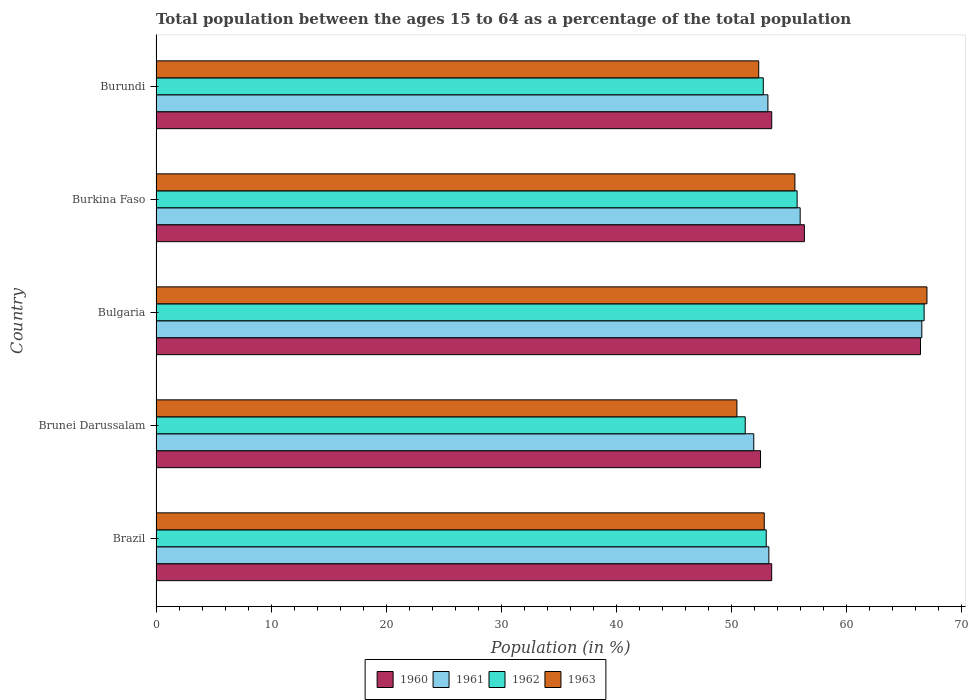How many different coloured bars are there?
Give a very brief answer. 4. How many groups of bars are there?
Your answer should be very brief. 5. Are the number of bars on each tick of the Y-axis equal?
Your answer should be very brief. Yes. What is the label of the 2nd group of bars from the top?
Your answer should be very brief. Burkina Faso. In how many cases, is the number of bars for a given country not equal to the number of legend labels?
Keep it short and to the point. 0. What is the percentage of the population ages 15 to 64 in 1960 in Burkina Faso?
Ensure brevity in your answer.  56.35. Across all countries, what is the maximum percentage of the population ages 15 to 64 in 1963?
Offer a terse response. 67. Across all countries, what is the minimum percentage of the population ages 15 to 64 in 1960?
Make the answer very short. 52.54. In which country was the percentage of the population ages 15 to 64 in 1961 minimum?
Give a very brief answer. Brunei Darussalam. What is the total percentage of the population ages 15 to 64 in 1961 in the graph?
Offer a terse response. 280.93. What is the difference between the percentage of the population ages 15 to 64 in 1960 in Brunei Darussalam and that in Bulgaria?
Your response must be concise. -13.9. What is the difference between the percentage of the population ages 15 to 64 in 1962 in Burkina Faso and the percentage of the population ages 15 to 64 in 1960 in Brazil?
Your answer should be compact. 2.21. What is the average percentage of the population ages 15 to 64 in 1961 per country?
Your response must be concise. 56.19. What is the difference between the percentage of the population ages 15 to 64 in 1960 and percentage of the population ages 15 to 64 in 1963 in Burkina Faso?
Ensure brevity in your answer.  0.82. In how many countries, is the percentage of the population ages 15 to 64 in 1960 greater than 60 ?
Make the answer very short. 1. What is the ratio of the percentage of the population ages 15 to 64 in 1961 in Bulgaria to that in Burkina Faso?
Your answer should be very brief. 1.19. Is the difference between the percentage of the population ages 15 to 64 in 1960 in Bulgaria and Burkina Faso greater than the difference between the percentage of the population ages 15 to 64 in 1963 in Bulgaria and Burkina Faso?
Ensure brevity in your answer.  No. What is the difference between the highest and the second highest percentage of the population ages 15 to 64 in 1963?
Provide a succinct answer. 11.48. What is the difference between the highest and the lowest percentage of the population ages 15 to 64 in 1962?
Provide a succinct answer. 15.55. Is it the case that in every country, the sum of the percentage of the population ages 15 to 64 in 1962 and percentage of the population ages 15 to 64 in 1960 is greater than the sum of percentage of the population ages 15 to 64 in 1963 and percentage of the population ages 15 to 64 in 1961?
Provide a succinct answer. No. What does the 1st bar from the top in Burkina Faso represents?
Make the answer very short. 1963. What does the 1st bar from the bottom in Burundi represents?
Offer a very short reply. 1960. Is it the case that in every country, the sum of the percentage of the population ages 15 to 64 in 1960 and percentage of the population ages 15 to 64 in 1962 is greater than the percentage of the population ages 15 to 64 in 1963?
Keep it short and to the point. Yes. How many bars are there?
Keep it short and to the point. 20. Are all the bars in the graph horizontal?
Make the answer very short. Yes. How many countries are there in the graph?
Make the answer very short. 5. Does the graph contain any zero values?
Offer a very short reply. No. Does the graph contain grids?
Offer a terse response. No. How are the legend labels stacked?
Ensure brevity in your answer.  Horizontal. What is the title of the graph?
Keep it short and to the point. Total population between the ages 15 to 64 as a percentage of the total population. Does "1968" appear as one of the legend labels in the graph?
Your response must be concise. No. What is the label or title of the Y-axis?
Provide a short and direct response. Country. What is the Population (in %) of 1960 in Brazil?
Ensure brevity in your answer.  53.51. What is the Population (in %) of 1961 in Brazil?
Provide a succinct answer. 53.26. What is the Population (in %) in 1962 in Brazil?
Keep it short and to the point. 53.03. What is the Population (in %) of 1963 in Brazil?
Your response must be concise. 52.86. What is the Population (in %) in 1960 in Brunei Darussalam?
Offer a very short reply. 52.54. What is the Population (in %) in 1961 in Brunei Darussalam?
Provide a succinct answer. 51.95. What is the Population (in %) of 1962 in Brunei Darussalam?
Offer a very short reply. 51.21. What is the Population (in %) of 1963 in Brunei Darussalam?
Provide a succinct answer. 50.48. What is the Population (in %) of 1960 in Bulgaria?
Ensure brevity in your answer.  66.44. What is the Population (in %) of 1961 in Bulgaria?
Your response must be concise. 66.56. What is the Population (in %) in 1962 in Bulgaria?
Provide a succinct answer. 66.76. What is the Population (in %) of 1963 in Bulgaria?
Offer a terse response. 67. What is the Population (in %) of 1960 in Burkina Faso?
Offer a terse response. 56.35. What is the Population (in %) of 1961 in Burkina Faso?
Provide a succinct answer. 55.98. What is the Population (in %) of 1962 in Burkina Faso?
Your response must be concise. 55.72. What is the Population (in %) in 1963 in Burkina Faso?
Your answer should be compact. 55.53. What is the Population (in %) of 1960 in Burundi?
Offer a terse response. 53.51. What is the Population (in %) in 1961 in Burundi?
Offer a terse response. 53.18. What is the Population (in %) in 1962 in Burundi?
Make the answer very short. 52.78. What is the Population (in %) of 1963 in Burundi?
Your response must be concise. 52.38. Across all countries, what is the maximum Population (in %) in 1960?
Your answer should be compact. 66.44. Across all countries, what is the maximum Population (in %) of 1961?
Give a very brief answer. 66.56. Across all countries, what is the maximum Population (in %) in 1962?
Make the answer very short. 66.76. Across all countries, what is the maximum Population (in %) in 1963?
Ensure brevity in your answer.  67. Across all countries, what is the minimum Population (in %) in 1960?
Give a very brief answer. 52.54. Across all countries, what is the minimum Population (in %) in 1961?
Make the answer very short. 51.95. Across all countries, what is the minimum Population (in %) of 1962?
Offer a terse response. 51.21. Across all countries, what is the minimum Population (in %) in 1963?
Provide a succinct answer. 50.48. What is the total Population (in %) in 1960 in the graph?
Give a very brief answer. 282.35. What is the total Population (in %) in 1961 in the graph?
Provide a short and direct response. 280.93. What is the total Population (in %) in 1962 in the graph?
Give a very brief answer. 279.5. What is the total Population (in %) of 1963 in the graph?
Your answer should be very brief. 278.26. What is the difference between the Population (in %) in 1960 in Brazil and that in Brunei Darussalam?
Keep it short and to the point. 0.97. What is the difference between the Population (in %) in 1961 in Brazil and that in Brunei Darussalam?
Ensure brevity in your answer.  1.31. What is the difference between the Population (in %) in 1962 in Brazil and that in Brunei Darussalam?
Your response must be concise. 1.82. What is the difference between the Population (in %) in 1963 in Brazil and that in Brunei Darussalam?
Provide a succinct answer. 2.38. What is the difference between the Population (in %) of 1960 in Brazil and that in Bulgaria?
Ensure brevity in your answer.  -12.93. What is the difference between the Population (in %) of 1961 in Brazil and that in Bulgaria?
Keep it short and to the point. -13.3. What is the difference between the Population (in %) in 1962 in Brazil and that in Bulgaria?
Keep it short and to the point. -13.72. What is the difference between the Population (in %) of 1963 in Brazil and that in Bulgaria?
Make the answer very short. -14.14. What is the difference between the Population (in %) of 1960 in Brazil and that in Burkina Faso?
Give a very brief answer. -2.84. What is the difference between the Population (in %) in 1961 in Brazil and that in Burkina Faso?
Provide a succinct answer. -2.72. What is the difference between the Population (in %) of 1962 in Brazil and that in Burkina Faso?
Provide a succinct answer. -2.68. What is the difference between the Population (in %) of 1963 in Brazil and that in Burkina Faso?
Your answer should be very brief. -2.67. What is the difference between the Population (in %) in 1960 in Brazil and that in Burundi?
Ensure brevity in your answer.  -0. What is the difference between the Population (in %) of 1961 in Brazil and that in Burundi?
Offer a terse response. 0.08. What is the difference between the Population (in %) of 1962 in Brazil and that in Burundi?
Your answer should be compact. 0.26. What is the difference between the Population (in %) of 1963 in Brazil and that in Burundi?
Make the answer very short. 0.48. What is the difference between the Population (in %) in 1960 in Brunei Darussalam and that in Bulgaria?
Ensure brevity in your answer.  -13.9. What is the difference between the Population (in %) in 1961 in Brunei Darussalam and that in Bulgaria?
Your answer should be compact. -14.61. What is the difference between the Population (in %) of 1962 in Brunei Darussalam and that in Bulgaria?
Give a very brief answer. -15.55. What is the difference between the Population (in %) in 1963 in Brunei Darussalam and that in Bulgaria?
Offer a terse response. -16.52. What is the difference between the Population (in %) in 1960 in Brunei Darussalam and that in Burkina Faso?
Make the answer very short. -3.81. What is the difference between the Population (in %) in 1961 in Brunei Darussalam and that in Burkina Faso?
Provide a short and direct response. -4.03. What is the difference between the Population (in %) of 1962 in Brunei Darussalam and that in Burkina Faso?
Offer a very short reply. -4.51. What is the difference between the Population (in %) of 1963 in Brunei Darussalam and that in Burkina Faso?
Offer a very short reply. -5.04. What is the difference between the Population (in %) of 1960 in Brunei Darussalam and that in Burundi?
Your response must be concise. -0.97. What is the difference between the Population (in %) in 1961 in Brunei Darussalam and that in Burundi?
Your answer should be compact. -1.23. What is the difference between the Population (in %) in 1962 in Brunei Darussalam and that in Burundi?
Provide a succinct answer. -1.57. What is the difference between the Population (in %) of 1963 in Brunei Darussalam and that in Burundi?
Keep it short and to the point. -1.9. What is the difference between the Population (in %) in 1960 in Bulgaria and that in Burkina Faso?
Provide a succinct answer. 10.09. What is the difference between the Population (in %) of 1961 in Bulgaria and that in Burkina Faso?
Your answer should be compact. 10.57. What is the difference between the Population (in %) in 1962 in Bulgaria and that in Burkina Faso?
Offer a terse response. 11.04. What is the difference between the Population (in %) in 1963 in Bulgaria and that in Burkina Faso?
Provide a succinct answer. 11.48. What is the difference between the Population (in %) in 1960 in Bulgaria and that in Burundi?
Your response must be concise. 12.93. What is the difference between the Population (in %) in 1961 in Bulgaria and that in Burundi?
Provide a succinct answer. 13.38. What is the difference between the Population (in %) in 1962 in Bulgaria and that in Burundi?
Provide a succinct answer. 13.98. What is the difference between the Population (in %) of 1963 in Bulgaria and that in Burundi?
Your answer should be compact. 14.62. What is the difference between the Population (in %) of 1960 in Burkina Faso and that in Burundi?
Your answer should be very brief. 2.84. What is the difference between the Population (in %) in 1961 in Burkina Faso and that in Burundi?
Make the answer very short. 2.8. What is the difference between the Population (in %) in 1962 in Burkina Faso and that in Burundi?
Offer a very short reply. 2.94. What is the difference between the Population (in %) in 1963 in Burkina Faso and that in Burundi?
Keep it short and to the point. 3.15. What is the difference between the Population (in %) of 1960 in Brazil and the Population (in %) of 1961 in Brunei Darussalam?
Keep it short and to the point. 1.56. What is the difference between the Population (in %) of 1960 in Brazil and the Population (in %) of 1962 in Brunei Darussalam?
Offer a terse response. 2.3. What is the difference between the Population (in %) in 1960 in Brazil and the Population (in %) in 1963 in Brunei Darussalam?
Ensure brevity in your answer.  3.02. What is the difference between the Population (in %) of 1961 in Brazil and the Population (in %) of 1962 in Brunei Darussalam?
Provide a short and direct response. 2.05. What is the difference between the Population (in %) of 1961 in Brazil and the Population (in %) of 1963 in Brunei Darussalam?
Ensure brevity in your answer.  2.78. What is the difference between the Population (in %) in 1962 in Brazil and the Population (in %) in 1963 in Brunei Darussalam?
Your response must be concise. 2.55. What is the difference between the Population (in %) in 1960 in Brazil and the Population (in %) in 1961 in Bulgaria?
Your response must be concise. -13.05. What is the difference between the Population (in %) of 1960 in Brazil and the Population (in %) of 1962 in Bulgaria?
Keep it short and to the point. -13.25. What is the difference between the Population (in %) of 1960 in Brazil and the Population (in %) of 1963 in Bulgaria?
Your response must be concise. -13.49. What is the difference between the Population (in %) of 1961 in Brazil and the Population (in %) of 1962 in Bulgaria?
Your answer should be very brief. -13.49. What is the difference between the Population (in %) in 1961 in Brazil and the Population (in %) in 1963 in Bulgaria?
Offer a terse response. -13.74. What is the difference between the Population (in %) in 1962 in Brazil and the Population (in %) in 1963 in Bulgaria?
Your response must be concise. -13.97. What is the difference between the Population (in %) in 1960 in Brazil and the Population (in %) in 1961 in Burkina Faso?
Offer a very short reply. -2.48. What is the difference between the Population (in %) in 1960 in Brazil and the Population (in %) in 1962 in Burkina Faso?
Your answer should be compact. -2.21. What is the difference between the Population (in %) in 1960 in Brazil and the Population (in %) in 1963 in Burkina Faso?
Offer a terse response. -2.02. What is the difference between the Population (in %) of 1961 in Brazil and the Population (in %) of 1962 in Burkina Faso?
Provide a succinct answer. -2.46. What is the difference between the Population (in %) in 1961 in Brazil and the Population (in %) in 1963 in Burkina Faso?
Ensure brevity in your answer.  -2.26. What is the difference between the Population (in %) of 1962 in Brazil and the Population (in %) of 1963 in Burkina Faso?
Provide a short and direct response. -2.49. What is the difference between the Population (in %) in 1960 in Brazil and the Population (in %) in 1961 in Burundi?
Offer a terse response. 0.33. What is the difference between the Population (in %) of 1960 in Brazil and the Population (in %) of 1962 in Burundi?
Offer a terse response. 0.73. What is the difference between the Population (in %) of 1960 in Brazil and the Population (in %) of 1963 in Burundi?
Your answer should be compact. 1.13. What is the difference between the Population (in %) of 1961 in Brazil and the Population (in %) of 1962 in Burundi?
Offer a terse response. 0.48. What is the difference between the Population (in %) in 1961 in Brazil and the Population (in %) in 1963 in Burundi?
Make the answer very short. 0.88. What is the difference between the Population (in %) in 1962 in Brazil and the Population (in %) in 1963 in Burundi?
Offer a terse response. 0.65. What is the difference between the Population (in %) of 1960 in Brunei Darussalam and the Population (in %) of 1961 in Bulgaria?
Your answer should be compact. -14.02. What is the difference between the Population (in %) of 1960 in Brunei Darussalam and the Population (in %) of 1962 in Bulgaria?
Offer a very short reply. -14.22. What is the difference between the Population (in %) in 1960 in Brunei Darussalam and the Population (in %) in 1963 in Bulgaria?
Your answer should be very brief. -14.46. What is the difference between the Population (in %) of 1961 in Brunei Darussalam and the Population (in %) of 1962 in Bulgaria?
Your answer should be very brief. -14.81. What is the difference between the Population (in %) in 1961 in Brunei Darussalam and the Population (in %) in 1963 in Bulgaria?
Give a very brief answer. -15.05. What is the difference between the Population (in %) in 1962 in Brunei Darussalam and the Population (in %) in 1963 in Bulgaria?
Keep it short and to the point. -15.79. What is the difference between the Population (in %) of 1960 in Brunei Darussalam and the Population (in %) of 1961 in Burkina Faso?
Your answer should be very brief. -3.44. What is the difference between the Population (in %) of 1960 in Brunei Darussalam and the Population (in %) of 1962 in Burkina Faso?
Provide a short and direct response. -3.18. What is the difference between the Population (in %) of 1960 in Brunei Darussalam and the Population (in %) of 1963 in Burkina Faso?
Provide a short and direct response. -2.99. What is the difference between the Population (in %) of 1961 in Brunei Darussalam and the Population (in %) of 1962 in Burkina Faso?
Ensure brevity in your answer.  -3.77. What is the difference between the Population (in %) in 1961 in Brunei Darussalam and the Population (in %) in 1963 in Burkina Faso?
Offer a terse response. -3.58. What is the difference between the Population (in %) in 1962 in Brunei Darussalam and the Population (in %) in 1963 in Burkina Faso?
Provide a succinct answer. -4.32. What is the difference between the Population (in %) in 1960 in Brunei Darussalam and the Population (in %) in 1961 in Burundi?
Make the answer very short. -0.64. What is the difference between the Population (in %) in 1960 in Brunei Darussalam and the Population (in %) in 1962 in Burundi?
Ensure brevity in your answer.  -0.24. What is the difference between the Population (in %) in 1960 in Brunei Darussalam and the Population (in %) in 1963 in Burundi?
Keep it short and to the point. 0.16. What is the difference between the Population (in %) of 1961 in Brunei Darussalam and the Population (in %) of 1962 in Burundi?
Your answer should be compact. -0.83. What is the difference between the Population (in %) in 1961 in Brunei Darussalam and the Population (in %) in 1963 in Burundi?
Keep it short and to the point. -0.43. What is the difference between the Population (in %) in 1962 in Brunei Darussalam and the Population (in %) in 1963 in Burundi?
Ensure brevity in your answer.  -1.17. What is the difference between the Population (in %) in 1960 in Bulgaria and the Population (in %) in 1961 in Burkina Faso?
Ensure brevity in your answer.  10.46. What is the difference between the Population (in %) in 1960 in Bulgaria and the Population (in %) in 1962 in Burkina Faso?
Offer a terse response. 10.72. What is the difference between the Population (in %) in 1960 in Bulgaria and the Population (in %) in 1963 in Burkina Faso?
Give a very brief answer. 10.91. What is the difference between the Population (in %) of 1961 in Bulgaria and the Population (in %) of 1962 in Burkina Faso?
Ensure brevity in your answer.  10.84. What is the difference between the Population (in %) in 1961 in Bulgaria and the Population (in %) in 1963 in Burkina Faso?
Offer a terse response. 11.03. What is the difference between the Population (in %) of 1962 in Bulgaria and the Population (in %) of 1963 in Burkina Faso?
Your answer should be very brief. 11.23. What is the difference between the Population (in %) in 1960 in Bulgaria and the Population (in %) in 1961 in Burundi?
Make the answer very short. 13.26. What is the difference between the Population (in %) of 1960 in Bulgaria and the Population (in %) of 1962 in Burundi?
Make the answer very short. 13.66. What is the difference between the Population (in %) of 1960 in Bulgaria and the Population (in %) of 1963 in Burundi?
Your response must be concise. 14.06. What is the difference between the Population (in %) in 1961 in Bulgaria and the Population (in %) in 1962 in Burundi?
Ensure brevity in your answer.  13.78. What is the difference between the Population (in %) in 1961 in Bulgaria and the Population (in %) in 1963 in Burundi?
Your response must be concise. 14.18. What is the difference between the Population (in %) in 1962 in Bulgaria and the Population (in %) in 1963 in Burundi?
Offer a terse response. 14.38. What is the difference between the Population (in %) in 1960 in Burkina Faso and the Population (in %) in 1961 in Burundi?
Your response must be concise. 3.17. What is the difference between the Population (in %) in 1960 in Burkina Faso and the Population (in %) in 1962 in Burundi?
Your answer should be very brief. 3.57. What is the difference between the Population (in %) in 1960 in Burkina Faso and the Population (in %) in 1963 in Burundi?
Provide a succinct answer. 3.97. What is the difference between the Population (in %) of 1961 in Burkina Faso and the Population (in %) of 1962 in Burundi?
Your answer should be compact. 3.21. What is the difference between the Population (in %) of 1961 in Burkina Faso and the Population (in %) of 1963 in Burundi?
Give a very brief answer. 3.6. What is the difference between the Population (in %) in 1962 in Burkina Faso and the Population (in %) in 1963 in Burundi?
Offer a very short reply. 3.34. What is the average Population (in %) in 1960 per country?
Make the answer very short. 56.47. What is the average Population (in %) of 1961 per country?
Provide a succinct answer. 56.19. What is the average Population (in %) in 1962 per country?
Offer a terse response. 55.9. What is the average Population (in %) in 1963 per country?
Your answer should be very brief. 55.65. What is the difference between the Population (in %) in 1960 and Population (in %) in 1961 in Brazil?
Give a very brief answer. 0.25. What is the difference between the Population (in %) of 1960 and Population (in %) of 1962 in Brazil?
Keep it short and to the point. 0.47. What is the difference between the Population (in %) in 1960 and Population (in %) in 1963 in Brazil?
Ensure brevity in your answer.  0.65. What is the difference between the Population (in %) in 1961 and Population (in %) in 1962 in Brazil?
Make the answer very short. 0.23. What is the difference between the Population (in %) in 1961 and Population (in %) in 1963 in Brazil?
Your answer should be compact. 0.4. What is the difference between the Population (in %) in 1962 and Population (in %) in 1963 in Brazil?
Offer a terse response. 0.17. What is the difference between the Population (in %) in 1960 and Population (in %) in 1961 in Brunei Darussalam?
Offer a terse response. 0.59. What is the difference between the Population (in %) in 1960 and Population (in %) in 1962 in Brunei Darussalam?
Keep it short and to the point. 1.33. What is the difference between the Population (in %) in 1960 and Population (in %) in 1963 in Brunei Darussalam?
Your answer should be compact. 2.05. What is the difference between the Population (in %) in 1961 and Population (in %) in 1962 in Brunei Darussalam?
Provide a short and direct response. 0.74. What is the difference between the Population (in %) of 1961 and Population (in %) of 1963 in Brunei Darussalam?
Give a very brief answer. 1.47. What is the difference between the Population (in %) in 1962 and Population (in %) in 1963 in Brunei Darussalam?
Offer a terse response. 0.72. What is the difference between the Population (in %) in 1960 and Population (in %) in 1961 in Bulgaria?
Offer a terse response. -0.12. What is the difference between the Population (in %) of 1960 and Population (in %) of 1962 in Bulgaria?
Your answer should be compact. -0.32. What is the difference between the Population (in %) of 1960 and Population (in %) of 1963 in Bulgaria?
Your answer should be compact. -0.56. What is the difference between the Population (in %) of 1961 and Population (in %) of 1962 in Bulgaria?
Make the answer very short. -0.2. What is the difference between the Population (in %) of 1961 and Population (in %) of 1963 in Bulgaria?
Provide a short and direct response. -0.44. What is the difference between the Population (in %) of 1962 and Population (in %) of 1963 in Bulgaria?
Provide a short and direct response. -0.24. What is the difference between the Population (in %) in 1960 and Population (in %) in 1961 in Burkina Faso?
Keep it short and to the point. 0.37. What is the difference between the Population (in %) in 1960 and Population (in %) in 1962 in Burkina Faso?
Your answer should be compact. 0.63. What is the difference between the Population (in %) of 1960 and Population (in %) of 1963 in Burkina Faso?
Make the answer very short. 0.82. What is the difference between the Population (in %) in 1961 and Population (in %) in 1962 in Burkina Faso?
Make the answer very short. 0.26. What is the difference between the Population (in %) of 1961 and Population (in %) of 1963 in Burkina Faso?
Your response must be concise. 0.46. What is the difference between the Population (in %) in 1962 and Population (in %) in 1963 in Burkina Faso?
Your response must be concise. 0.19. What is the difference between the Population (in %) in 1960 and Population (in %) in 1961 in Burundi?
Offer a terse response. 0.33. What is the difference between the Population (in %) in 1960 and Population (in %) in 1962 in Burundi?
Give a very brief answer. 0.73. What is the difference between the Population (in %) of 1960 and Population (in %) of 1963 in Burundi?
Offer a very short reply. 1.13. What is the difference between the Population (in %) of 1961 and Population (in %) of 1962 in Burundi?
Your answer should be compact. 0.4. What is the difference between the Population (in %) in 1961 and Population (in %) in 1963 in Burundi?
Keep it short and to the point. 0.8. What is the difference between the Population (in %) of 1962 and Population (in %) of 1963 in Burundi?
Provide a short and direct response. 0.4. What is the ratio of the Population (in %) in 1960 in Brazil to that in Brunei Darussalam?
Offer a very short reply. 1.02. What is the ratio of the Population (in %) in 1961 in Brazil to that in Brunei Darussalam?
Give a very brief answer. 1.03. What is the ratio of the Population (in %) in 1962 in Brazil to that in Brunei Darussalam?
Your answer should be very brief. 1.04. What is the ratio of the Population (in %) in 1963 in Brazil to that in Brunei Darussalam?
Keep it short and to the point. 1.05. What is the ratio of the Population (in %) of 1960 in Brazil to that in Bulgaria?
Your response must be concise. 0.81. What is the ratio of the Population (in %) of 1961 in Brazil to that in Bulgaria?
Keep it short and to the point. 0.8. What is the ratio of the Population (in %) in 1962 in Brazil to that in Bulgaria?
Ensure brevity in your answer.  0.79. What is the ratio of the Population (in %) in 1963 in Brazil to that in Bulgaria?
Offer a very short reply. 0.79. What is the ratio of the Population (in %) in 1960 in Brazil to that in Burkina Faso?
Keep it short and to the point. 0.95. What is the ratio of the Population (in %) of 1961 in Brazil to that in Burkina Faso?
Give a very brief answer. 0.95. What is the ratio of the Population (in %) of 1962 in Brazil to that in Burkina Faso?
Offer a terse response. 0.95. What is the ratio of the Population (in %) in 1963 in Brazil to that in Burkina Faso?
Your answer should be very brief. 0.95. What is the ratio of the Population (in %) in 1961 in Brazil to that in Burundi?
Provide a succinct answer. 1. What is the ratio of the Population (in %) in 1962 in Brazil to that in Burundi?
Provide a succinct answer. 1. What is the ratio of the Population (in %) of 1963 in Brazil to that in Burundi?
Offer a terse response. 1.01. What is the ratio of the Population (in %) of 1960 in Brunei Darussalam to that in Bulgaria?
Make the answer very short. 0.79. What is the ratio of the Population (in %) in 1961 in Brunei Darussalam to that in Bulgaria?
Offer a very short reply. 0.78. What is the ratio of the Population (in %) of 1962 in Brunei Darussalam to that in Bulgaria?
Give a very brief answer. 0.77. What is the ratio of the Population (in %) of 1963 in Brunei Darussalam to that in Bulgaria?
Make the answer very short. 0.75. What is the ratio of the Population (in %) of 1960 in Brunei Darussalam to that in Burkina Faso?
Keep it short and to the point. 0.93. What is the ratio of the Population (in %) in 1961 in Brunei Darussalam to that in Burkina Faso?
Give a very brief answer. 0.93. What is the ratio of the Population (in %) of 1962 in Brunei Darussalam to that in Burkina Faso?
Provide a short and direct response. 0.92. What is the ratio of the Population (in %) of 1963 in Brunei Darussalam to that in Burkina Faso?
Your answer should be very brief. 0.91. What is the ratio of the Population (in %) in 1960 in Brunei Darussalam to that in Burundi?
Offer a terse response. 0.98. What is the ratio of the Population (in %) of 1961 in Brunei Darussalam to that in Burundi?
Your response must be concise. 0.98. What is the ratio of the Population (in %) in 1962 in Brunei Darussalam to that in Burundi?
Offer a very short reply. 0.97. What is the ratio of the Population (in %) in 1963 in Brunei Darussalam to that in Burundi?
Offer a very short reply. 0.96. What is the ratio of the Population (in %) in 1960 in Bulgaria to that in Burkina Faso?
Offer a very short reply. 1.18. What is the ratio of the Population (in %) of 1961 in Bulgaria to that in Burkina Faso?
Offer a very short reply. 1.19. What is the ratio of the Population (in %) in 1962 in Bulgaria to that in Burkina Faso?
Keep it short and to the point. 1.2. What is the ratio of the Population (in %) in 1963 in Bulgaria to that in Burkina Faso?
Provide a succinct answer. 1.21. What is the ratio of the Population (in %) in 1960 in Bulgaria to that in Burundi?
Make the answer very short. 1.24. What is the ratio of the Population (in %) in 1961 in Bulgaria to that in Burundi?
Give a very brief answer. 1.25. What is the ratio of the Population (in %) in 1962 in Bulgaria to that in Burundi?
Give a very brief answer. 1.26. What is the ratio of the Population (in %) of 1963 in Bulgaria to that in Burundi?
Give a very brief answer. 1.28. What is the ratio of the Population (in %) of 1960 in Burkina Faso to that in Burundi?
Offer a very short reply. 1.05. What is the ratio of the Population (in %) of 1961 in Burkina Faso to that in Burundi?
Your response must be concise. 1.05. What is the ratio of the Population (in %) of 1962 in Burkina Faso to that in Burundi?
Your answer should be compact. 1.06. What is the ratio of the Population (in %) of 1963 in Burkina Faso to that in Burundi?
Ensure brevity in your answer.  1.06. What is the difference between the highest and the second highest Population (in %) of 1960?
Provide a short and direct response. 10.09. What is the difference between the highest and the second highest Population (in %) in 1961?
Provide a short and direct response. 10.57. What is the difference between the highest and the second highest Population (in %) of 1962?
Keep it short and to the point. 11.04. What is the difference between the highest and the second highest Population (in %) of 1963?
Your answer should be compact. 11.48. What is the difference between the highest and the lowest Population (in %) of 1960?
Offer a terse response. 13.9. What is the difference between the highest and the lowest Population (in %) of 1961?
Offer a terse response. 14.61. What is the difference between the highest and the lowest Population (in %) in 1962?
Make the answer very short. 15.55. What is the difference between the highest and the lowest Population (in %) in 1963?
Ensure brevity in your answer.  16.52. 